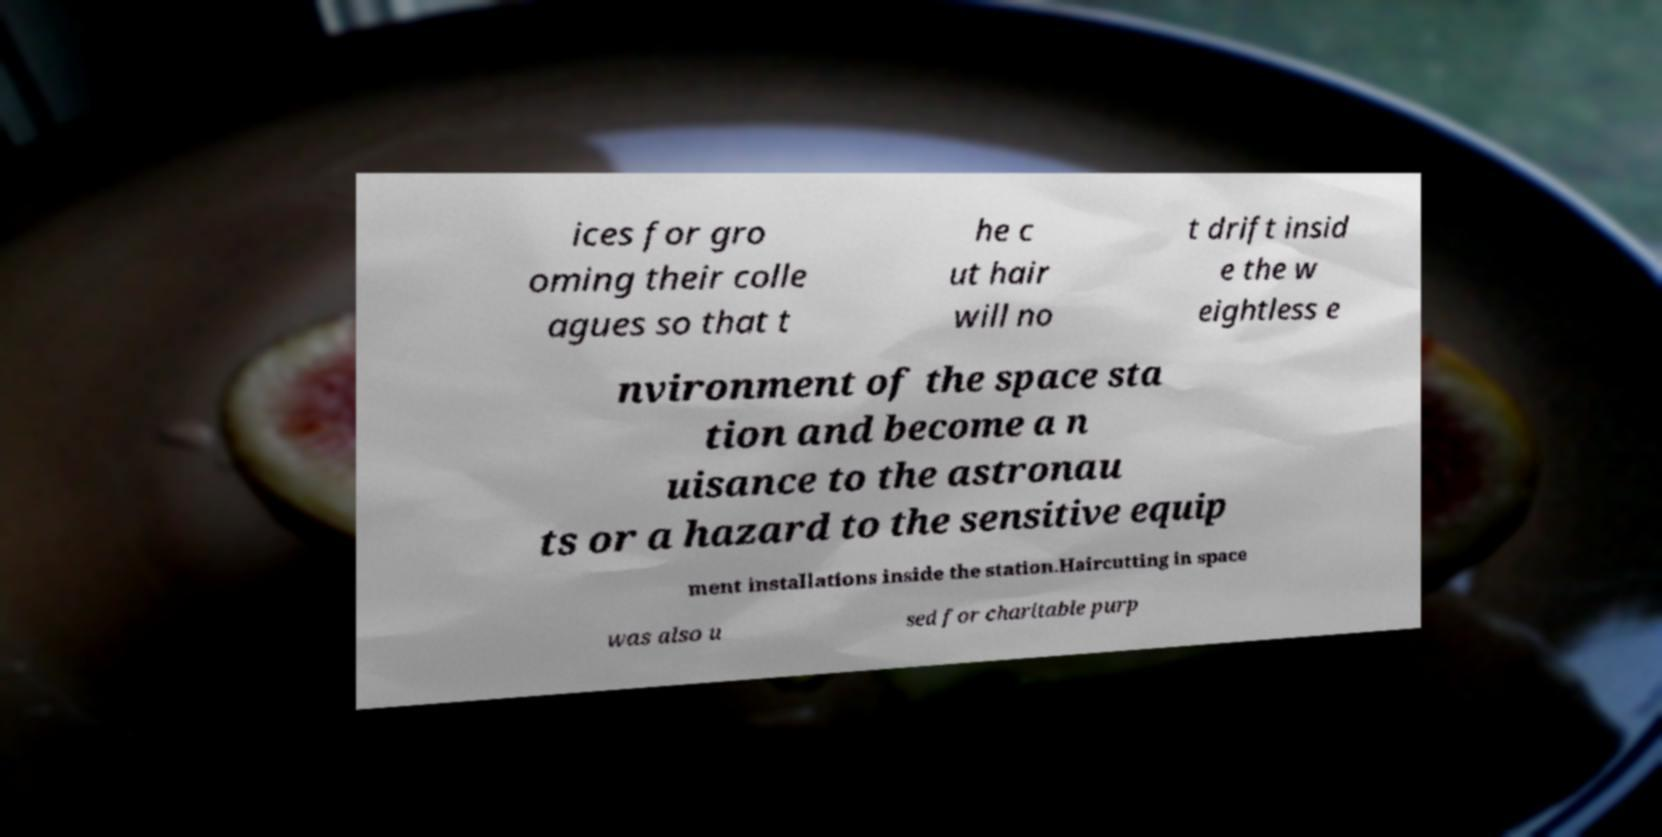Can you accurately transcribe the text from the provided image for me? ices for gro oming their colle agues so that t he c ut hair will no t drift insid e the w eightless e nvironment of the space sta tion and become a n uisance to the astronau ts or a hazard to the sensitive equip ment installations inside the station.Haircutting in space was also u sed for charitable purp 